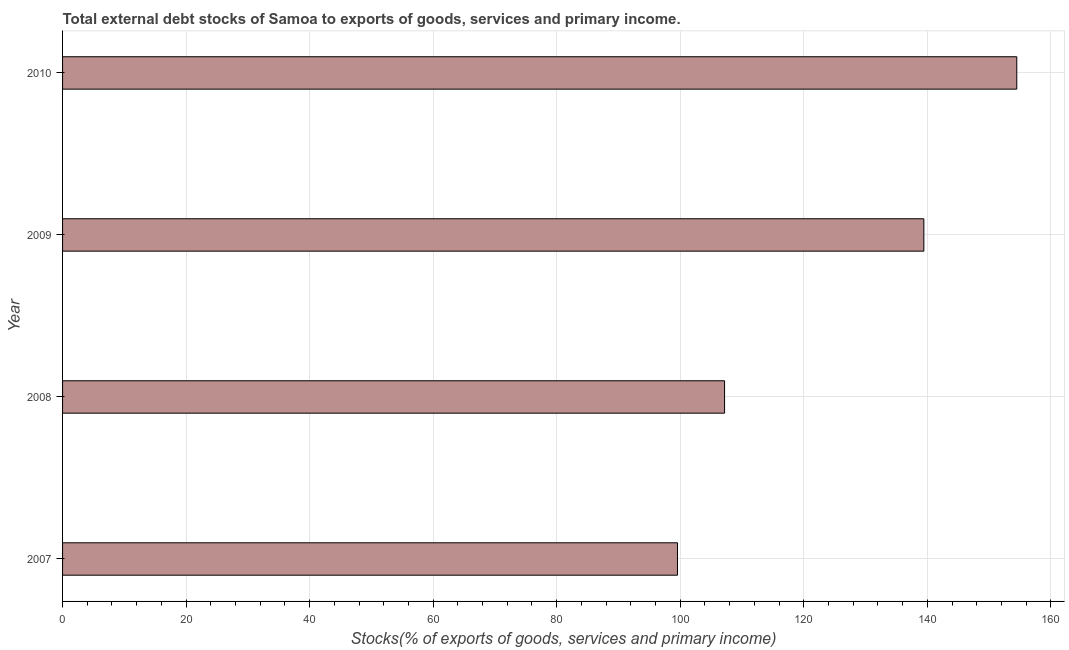What is the title of the graph?
Provide a succinct answer. Total external debt stocks of Samoa to exports of goods, services and primary income. What is the label or title of the X-axis?
Your answer should be very brief. Stocks(% of exports of goods, services and primary income). What is the external debt stocks in 2009?
Keep it short and to the point. 139.44. Across all years, what is the maximum external debt stocks?
Provide a succinct answer. 154.49. Across all years, what is the minimum external debt stocks?
Offer a very short reply. 99.56. In which year was the external debt stocks minimum?
Your answer should be compact. 2007. What is the sum of the external debt stocks?
Provide a short and direct response. 500.66. What is the difference between the external debt stocks in 2008 and 2010?
Provide a short and direct response. -47.31. What is the average external debt stocks per year?
Provide a short and direct response. 125.17. What is the median external debt stocks?
Ensure brevity in your answer.  123.31. In how many years, is the external debt stocks greater than 44 %?
Provide a succinct answer. 4. Do a majority of the years between 2009 and 2007 (inclusive) have external debt stocks greater than 48 %?
Give a very brief answer. Yes. What is the ratio of the external debt stocks in 2007 to that in 2009?
Your answer should be compact. 0.71. Is the difference between the external debt stocks in 2007 and 2010 greater than the difference between any two years?
Offer a very short reply. Yes. What is the difference between the highest and the second highest external debt stocks?
Your answer should be compact. 15.05. Is the sum of the external debt stocks in 2008 and 2009 greater than the maximum external debt stocks across all years?
Offer a very short reply. Yes. What is the difference between the highest and the lowest external debt stocks?
Provide a short and direct response. 54.93. Are all the bars in the graph horizontal?
Ensure brevity in your answer.  Yes. How many years are there in the graph?
Make the answer very short. 4. Are the values on the major ticks of X-axis written in scientific E-notation?
Your answer should be very brief. No. What is the Stocks(% of exports of goods, services and primary income) of 2007?
Make the answer very short. 99.56. What is the Stocks(% of exports of goods, services and primary income) of 2008?
Offer a very short reply. 107.18. What is the Stocks(% of exports of goods, services and primary income) of 2009?
Keep it short and to the point. 139.44. What is the Stocks(% of exports of goods, services and primary income) of 2010?
Provide a short and direct response. 154.49. What is the difference between the Stocks(% of exports of goods, services and primary income) in 2007 and 2008?
Give a very brief answer. -7.62. What is the difference between the Stocks(% of exports of goods, services and primary income) in 2007 and 2009?
Provide a succinct answer. -39.89. What is the difference between the Stocks(% of exports of goods, services and primary income) in 2007 and 2010?
Provide a succinct answer. -54.93. What is the difference between the Stocks(% of exports of goods, services and primary income) in 2008 and 2009?
Ensure brevity in your answer.  -32.26. What is the difference between the Stocks(% of exports of goods, services and primary income) in 2008 and 2010?
Your answer should be compact. -47.31. What is the difference between the Stocks(% of exports of goods, services and primary income) in 2009 and 2010?
Your answer should be compact. -15.05. What is the ratio of the Stocks(% of exports of goods, services and primary income) in 2007 to that in 2008?
Your answer should be compact. 0.93. What is the ratio of the Stocks(% of exports of goods, services and primary income) in 2007 to that in 2009?
Your answer should be very brief. 0.71. What is the ratio of the Stocks(% of exports of goods, services and primary income) in 2007 to that in 2010?
Ensure brevity in your answer.  0.64. What is the ratio of the Stocks(% of exports of goods, services and primary income) in 2008 to that in 2009?
Keep it short and to the point. 0.77. What is the ratio of the Stocks(% of exports of goods, services and primary income) in 2008 to that in 2010?
Your answer should be very brief. 0.69. What is the ratio of the Stocks(% of exports of goods, services and primary income) in 2009 to that in 2010?
Ensure brevity in your answer.  0.9. 